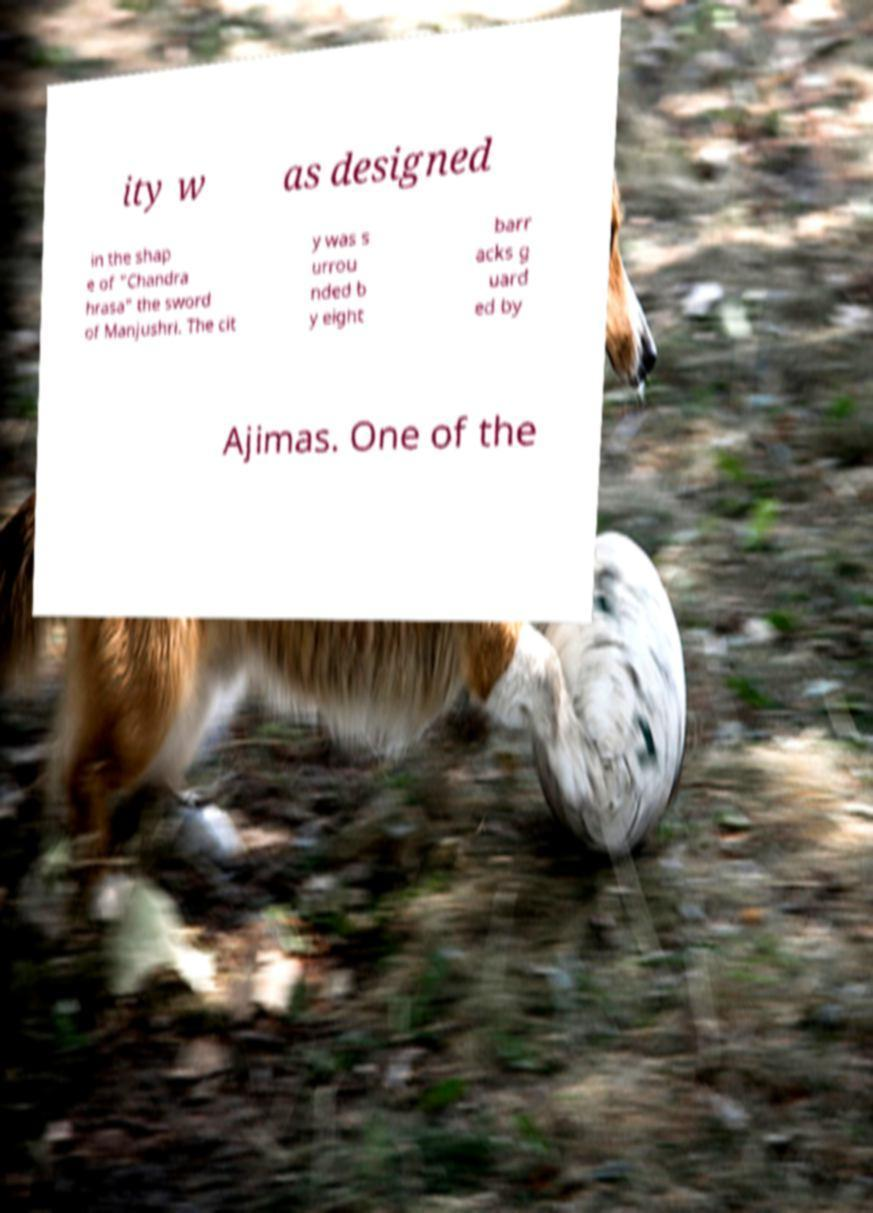There's text embedded in this image that I need extracted. Can you transcribe it verbatim? ity w as designed in the shap e of "Chandra hrasa" the sword of Manjushri. The cit y was s urrou nded b y eight barr acks g uard ed by Ajimas. One of the 